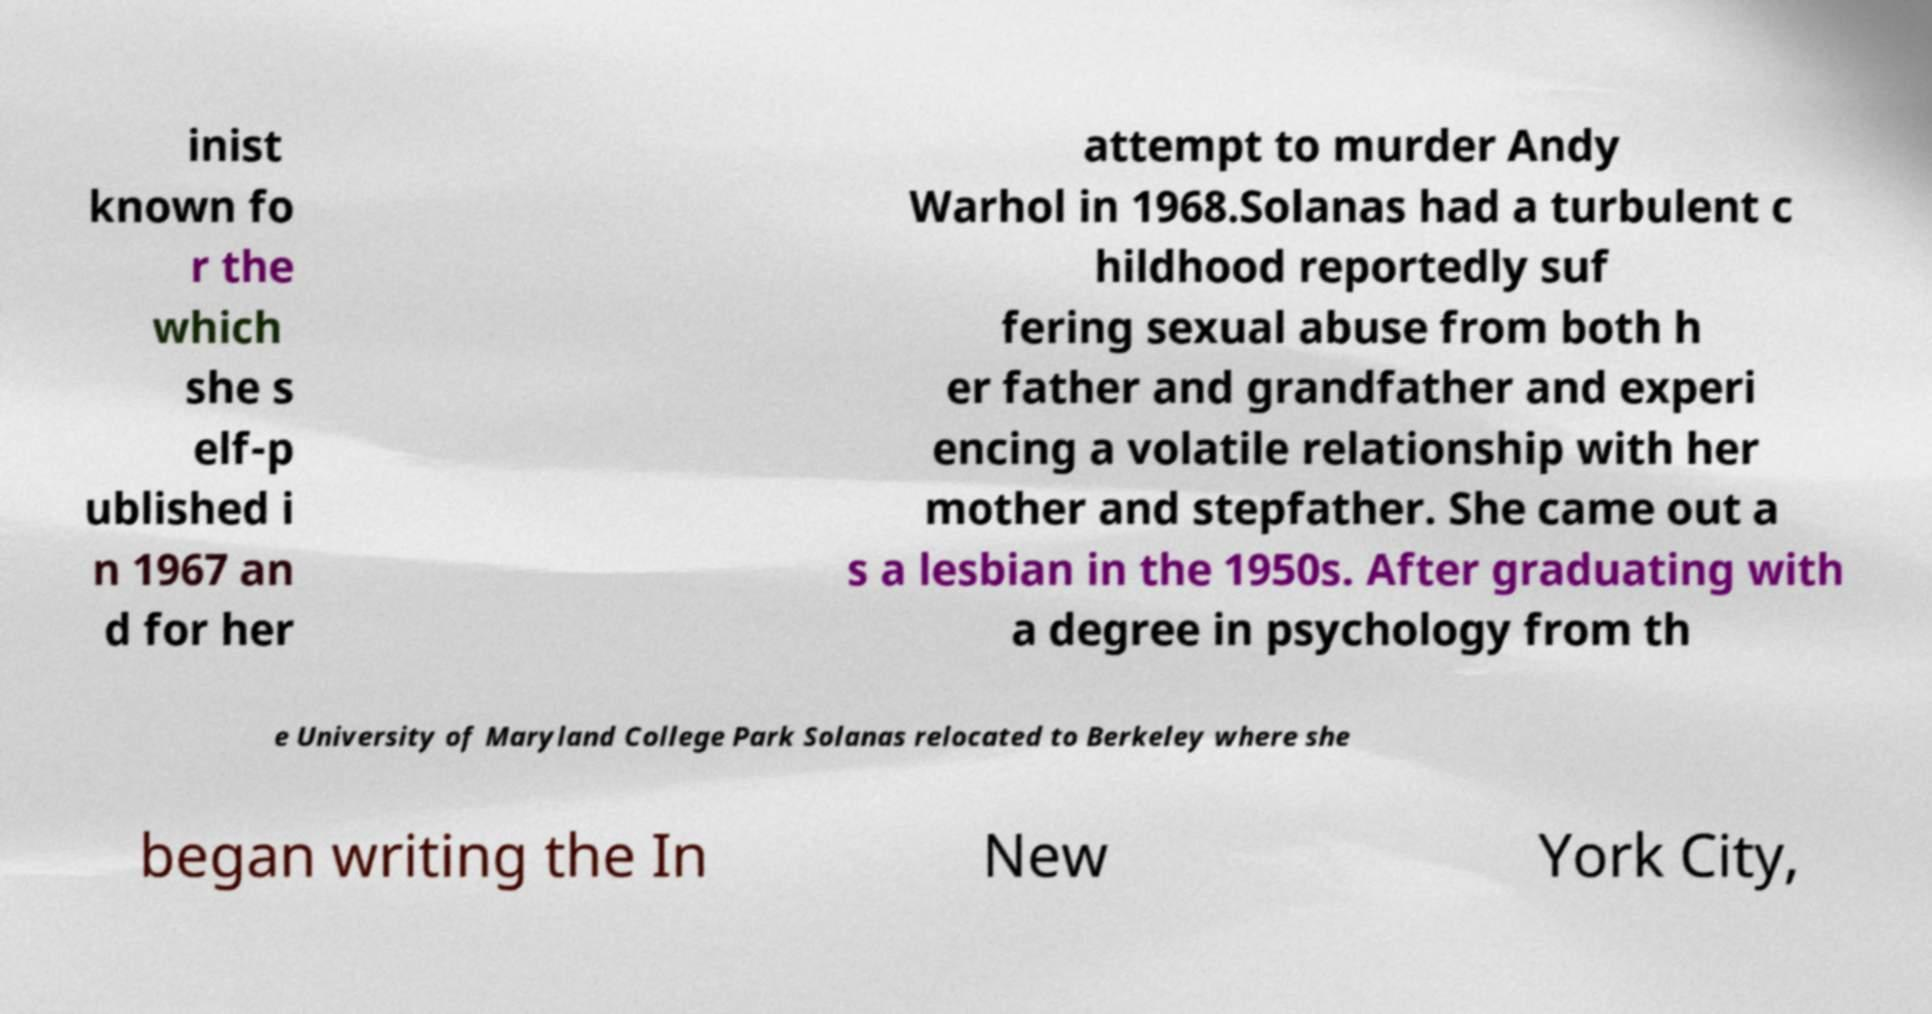Can you read and provide the text displayed in the image?This photo seems to have some interesting text. Can you extract and type it out for me? inist known fo r the which she s elf-p ublished i n 1967 an d for her attempt to murder Andy Warhol in 1968.Solanas had a turbulent c hildhood reportedly suf fering sexual abuse from both h er father and grandfather and experi encing a volatile relationship with her mother and stepfather. She came out a s a lesbian in the 1950s. After graduating with a degree in psychology from th e University of Maryland College Park Solanas relocated to Berkeley where she began writing the In New York City, 